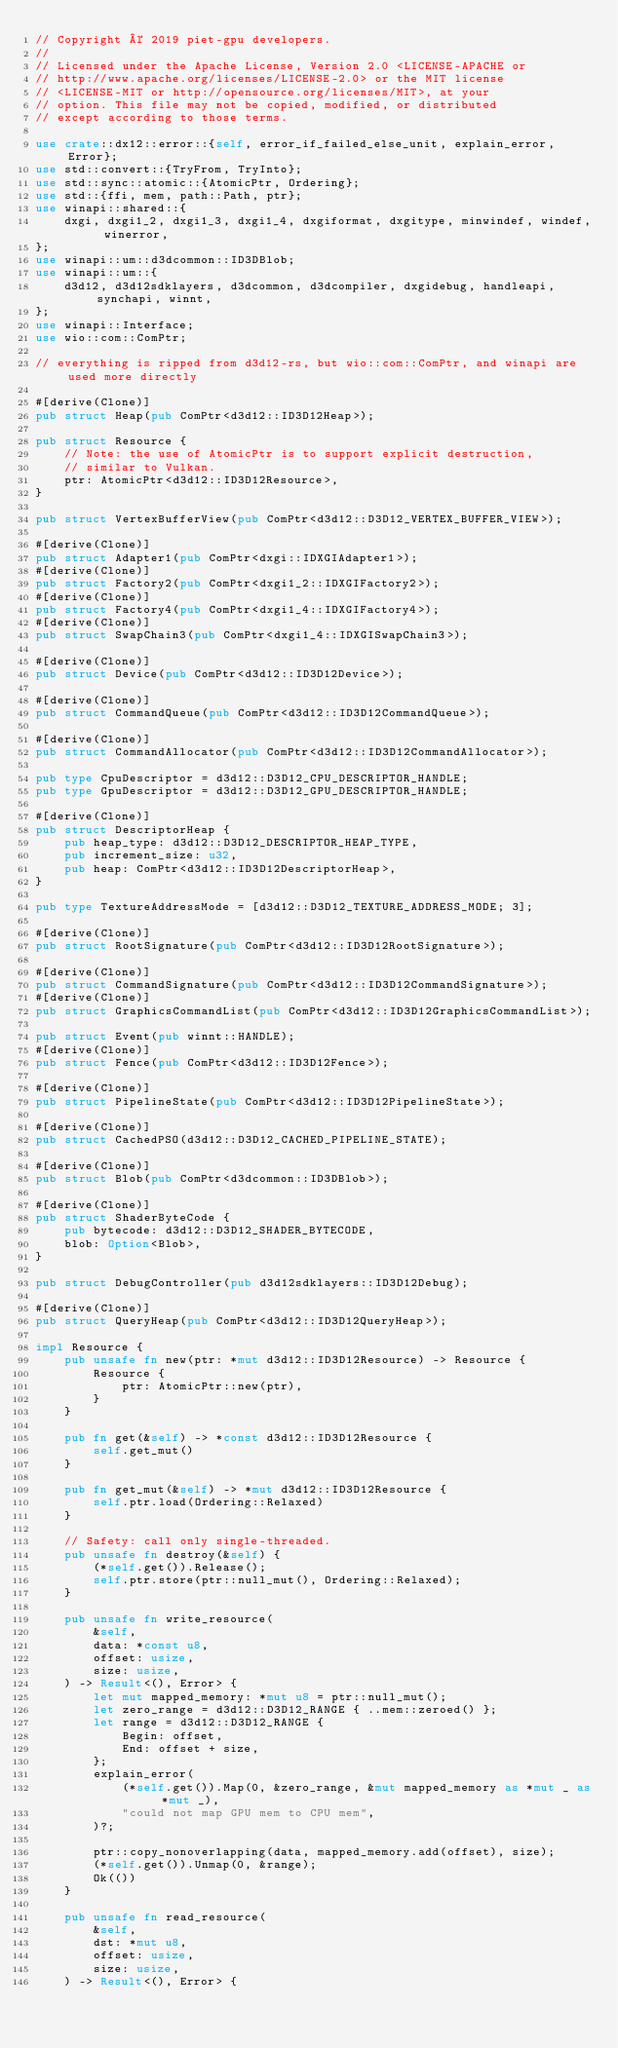<code> <loc_0><loc_0><loc_500><loc_500><_Rust_>// Copyright © 2019 piet-gpu developers.
//
// Licensed under the Apache License, Version 2.0 <LICENSE-APACHE or
// http://www.apache.org/licenses/LICENSE-2.0> or the MIT license
// <LICENSE-MIT or http://opensource.org/licenses/MIT>, at your
// option. This file may not be copied, modified, or distributed
// except according to those terms.

use crate::dx12::error::{self, error_if_failed_else_unit, explain_error, Error};
use std::convert::{TryFrom, TryInto};
use std::sync::atomic::{AtomicPtr, Ordering};
use std::{ffi, mem, path::Path, ptr};
use winapi::shared::{
    dxgi, dxgi1_2, dxgi1_3, dxgi1_4, dxgiformat, dxgitype, minwindef, windef, winerror,
};
use winapi::um::d3dcommon::ID3DBlob;
use winapi::um::{
    d3d12, d3d12sdklayers, d3dcommon, d3dcompiler, dxgidebug, handleapi, synchapi, winnt,
};
use winapi::Interface;
use wio::com::ComPtr;

// everything is ripped from d3d12-rs, but wio::com::ComPtr, and winapi are used more directly

#[derive(Clone)]
pub struct Heap(pub ComPtr<d3d12::ID3D12Heap>);

pub struct Resource {
    // Note: the use of AtomicPtr is to support explicit destruction,
    // similar to Vulkan.
    ptr: AtomicPtr<d3d12::ID3D12Resource>,
}

pub struct VertexBufferView(pub ComPtr<d3d12::D3D12_VERTEX_BUFFER_VIEW>);

#[derive(Clone)]
pub struct Adapter1(pub ComPtr<dxgi::IDXGIAdapter1>);
#[derive(Clone)]
pub struct Factory2(pub ComPtr<dxgi1_2::IDXGIFactory2>);
#[derive(Clone)]
pub struct Factory4(pub ComPtr<dxgi1_4::IDXGIFactory4>);
#[derive(Clone)]
pub struct SwapChain3(pub ComPtr<dxgi1_4::IDXGISwapChain3>);

#[derive(Clone)]
pub struct Device(pub ComPtr<d3d12::ID3D12Device>);

#[derive(Clone)]
pub struct CommandQueue(pub ComPtr<d3d12::ID3D12CommandQueue>);

#[derive(Clone)]
pub struct CommandAllocator(pub ComPtr<d3d12::ID3D12CommandAllocator>);

pub type CpuDescriptor = d3d12::D3D12_CPU_DESCRIPTOR_HANDLE;
pub type GpuDescriptor = d3d12::D3D12_GPU_DESCRIPTOR_HANDLE;

#[derive(Clone)]
pub struct DescriptorHeap {
    pub heap_type: d3d12::D3D12_DESCRIPTOR_HEAP_TYPE,
    pub increment_size: u32,
    pub heap: ComPtr<d3d12::ID3D12DescriptorHeap>,
}

pub type TextureAddressMode = [d3d12::D3D12_TEXTURE_ADDRESS_MODE; 3];

#[derive(Clone)]
pub struct RootSignature(pub ComPtr<d3d12::ID3D12RootSignature>);

#[derive(Clone)]
pub struct CommandSignature(pub ComPtr<d3d12::ID3D12CommandSignature>);
#[derive(Clone)]
pub struct GraphicsCommandList(pub ComPtr<d3d12::ID3D12GraphicsCommandList>);

pub struct Event(pub winnt::HANDLE);
#[derive(Clone)]
pub struct Fence(pub ComPtr<d3d12::ID3D12Fence>);

#[derive(Clone)]
pub struct PipelineState(pub ComPtr<d3d12::ID3D12PipelineState>);

#[derive(Clone)]
pub struct CachedPSO(d3d12::D3D12_CACHED_PIPELINE_STATE);

#[derive(Clone)]
pub struct Blob(pub ComPtr<d3dcommon::ID3DBlob>);

#[derive(Clone)]
pub struct ShaderByteCode {
    pub bytecode: d3d12::D3D12_SHADER_BYTECODE,
    blob: Option<Blob>,
}

pub struct DebugController(pub d3d12sdklayers::ID3D12Debug);

#[derive(Clone)]
pub struct QueryHeap(pub ComPtr<d3d12::ID3D12QueryHeap>);

impl Resource {
    pub unsafe fn new(ptr: *mut d3d12::ID3D12Resource) -> Resource {
        Resource {
            ptr: AtomicPtr::new(ptr),
        }
    }

    pub fn get(&self) -> *const d3d12::ID3D12Resource {
        self.get_mut()
    }

    pub fn get_mut(&self) -> *mut d3d12::ID3D12Resource {
        self.ptr.load(Ordering::Relaxed)
    }

    // Safety: call only single-threaded.
    pub unsafe fn destroy(&self) {
        (*self.get()).Release();
        self.ptr.store(ptr::null_mut(), Ordering::Relaxed);
    }

    pub unsafe fn write_resource(
        &self,
        data: *const u8,
        offset: usize,
        size: usize,
    ) -> Result<(), Error> {
        let mut mapped_memory: *mut u8 = ptr::null_mut();
        let zero_range = d3d12::D3D12_RANGE { ..mem::zeroed() };
        let range = d3d12::D3D12_RANGE {
            Begin: offset,
            End: offset + size,
        };
        explain_error(
            (*self.get()).Map(0, &zero_range, &mut mapped_memory as *mut _ as *mut _),
            "could not map GPU mem to CPU mem",
        )?;

        ptr::copy_nonoverlapping(data, mapped_memory.add(offset), size);
        (*self.get()).Unmap(0, &range);
        Ok(())
    }

    pub unsafe fn read_resource(
        &self,
        dst: *mut u8,
        offset: usize,
        size: usize,
    ) -> Result<(), Error> {</code> 